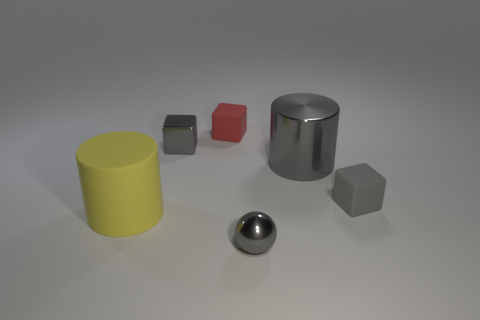How many other objects are there of the same color as the metal cylinder?
Ensure brevity in your answer.  3. How many brown things are tiny balls or large shiny cylinders?
Give a very brief answer. 0. There is a thing that is on the right side of the shiny cube and behind the large metal object; what is its color?
Your answer should be very brief. Red. What number of small things are either metallic spheres or gray rubber cubes?
Keep it short and to the point. 2. There is another object that is the same shape as the big yellow matte thing; what is its size?
Ensure brevity in your answer.  Large. What is the shape of the tiny red object?
Your answer should be compact. Cube. Is the material of the small ball the same as the big thing that is in front of the gray matte cube?
Offer a very short reply. No. What number of matte objects are either big brown cylinders or gray cylinders?
Ensure brevity in your answer.  0. There is a rubber object to the right of the gray cylinder; what is its size?
Give a very brief answer. Small. The gray object that is made of the same material as the red block is what size?
Offer a terse response. Small. 